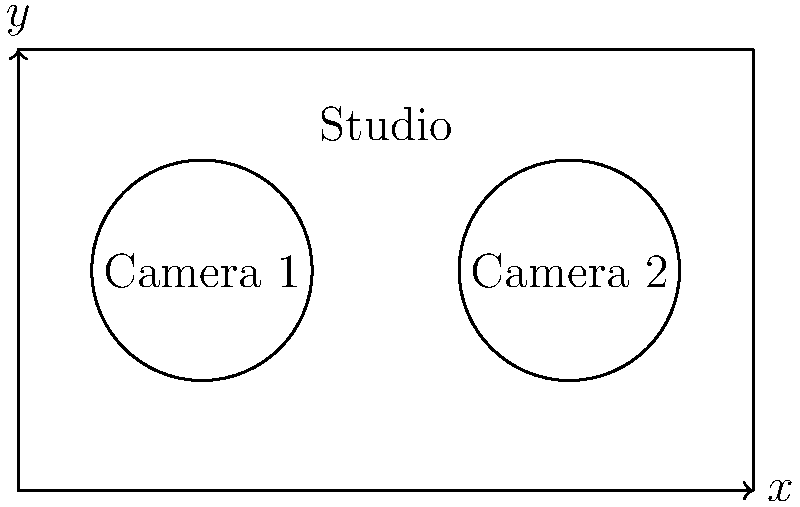As a television show producer, you're tasked with optimizing the layout of a rectangular studio measuring 10 meters by 6 meters. Two circular camera zones, each with a radius of 1.5 meters, need to be positioned along the length of the studio. The centers of these zones must be equidistant from the studio's sides and each other. What is the maximum distance possible between the centers of the two camera zones? Express your answer in meters. Let's approach this step-by-step:

1) The studio is 10 meters long. Let's call the distance between the centers of the camera zones $d$.

2) Each camera zone has a radius of 1.5 meters, so its diameter is 3 meters.

3) The distance from the edge of the studio to the center of the first camera zone must be equal to the distance from the center of the second camera zone to the opposite edge of the studio. Let's call this distance $x$.

4) We can express this as an equation:
   $x + d + x = 10$

5) Simplifying:
   $2x + d = 10$

6) We want to maximize $d$, which means we need to minimize $x$. However, $x$ can't be smaller than the radius of the camera zone (1.5 meters), or the zone would extend outside the studio.

7) Therefore, the optimal solution is when $x = 1.5$:
   $2(1.5) + d = 10$
   $3 + d = 10$
   $d = 7$

Thus, the maximum distance between the centers of the two camera zones is 7 meters.
Answer: 7 meters 